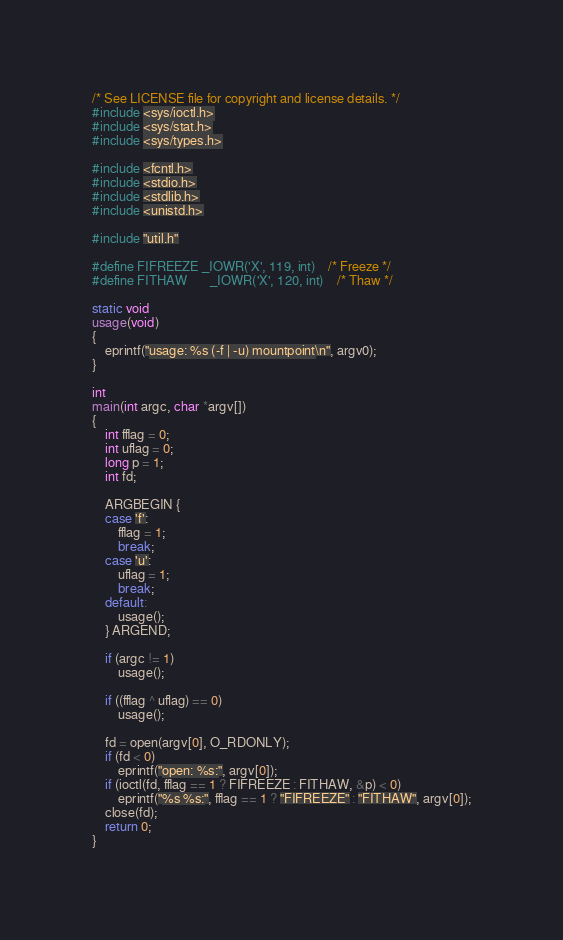<code> <loc_0><loc_0><loc_500><loc_500><_C_>/* See LICENSE file for copyright and license details. */
#include <sys/ioctl.h>
#include <sys/stat.h>
#include <sys/types.h>

#include <fcntl.h>
#include <stdio.h>
#include <stdlib.h>
#include <unistd.h>

#include "util.h"

#define FIFREEZE	_IOWR('X', 119, int)	/* Freeze */
#define FITHAW		_IOWR('X', 120, int)	/* Thaw */

static void
usage(void)
{
	eprintf("usage: %s (-f | -u) mountpoint\n", argv0);
}

int
main(int argc, char *argv[])
{
	int fflag = 0;
	int uflag = 0;
	long p = 1;
	int fd;

	ARGBEGIN {
	case 'f':
		fflag = 1;
		break;
	case 'u':
		uflag = 1;
		break;
	default:
		usage();
	} ARGEND;

	if (argc != 1)
		usage();

	if ((fflag ^ uflag) == 0)
		usage();

	fd = open(argv[0], O_RDONLY);
	if (fd < 0)
		eprintf("open: %s:", argv[0]);
	if (ioctl(fd, fflag == 1 ? FIFREEZE : FITHAW, &p) < 0)
		eprintf("%s %s:", fflag == 1 ? "FIFREEZE" : "FITHAW", argv[0]);
	close(fd);
	return 0;
}
</code> 